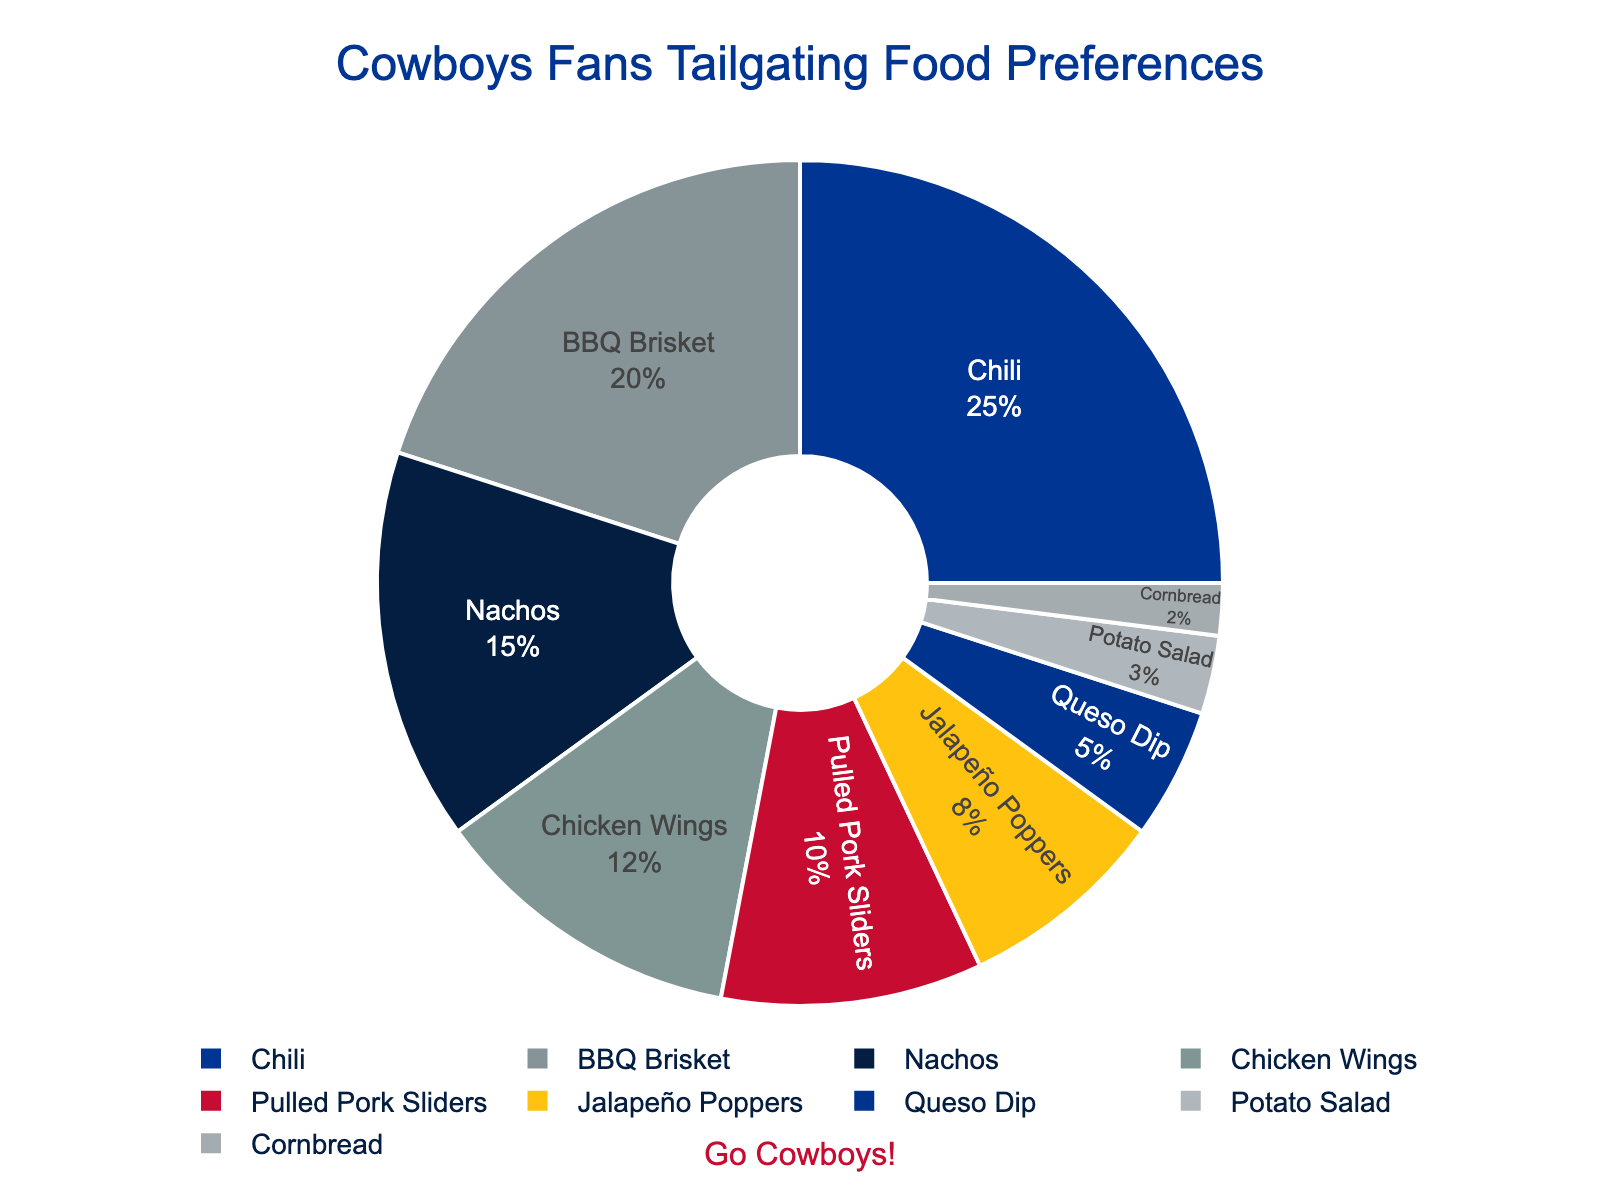What is the most preferred tailgating food item among Cowboys fans? The figure shows different food items with their percentages. The segment with the largest percentage is the most preferred.
Answer: Chili Which food item is less preferred: Chicken Wings or Pulled Pork Sliders? Locate both food items on the pie chart and compare their percentages. Chicken Wings have 12% and Pulled Pork Sliders have 10%.
Answer: Pulled Pork Sliders What’s the combined percentage of BBQ Brisket and Queso Dip? Identify the percentages for BBQ Brisket (20%) and Queso Dip (5%). Add them together: 20% + 5% = 25%.
Answer: 25% Among Jalapeño Poppers, Potato Salad, and Cornbread, which one has the second highest preference? Jalapeño Poppers have 8%, Potato Salad has 3%, and Cornbread has 2%. The second highest percentage among these is Potato Salad at 3%.
Answer: Potato Salad How much more popular is Nachos compared to Queso Dip? Nachos have a percentage of 15% while Queso Dip has 5%. Calculate the difference: 15% - 5% = 10%.
Answer: 10% Which food items have a combined percentage of 50%? Sum the percentages of food items one by one until reaching or exceeding 50%. Chili (25%) + BBQ Brisket (20%) + Nachos (15%) exceeds 50%.
Answer: Chili, BBQ Brisket, and Nachos What is the least preferred tailgating food item? Locate the smallest segment in the pie chart, which represents the least preferred food item. Cornbread is the smallest at 2%.
Answer: Cornbread Is the combined percentage of Chicken Wings and Pulled Pork Sliders greater than that of BBQ Brisket? Chicken Wings (12%) + Pulled Pork Sliders (10%) gives a combined percentage of 22%. Compare it with BBQ Brisket’s percentage (20%).
Answer: Yes Which two food items together make up the same percentage as Chili alone? Chili has 25%. Identify two items that sum up to 25%. BBQ Brisket (20%) + Queso Dip (5%) = 25%.
Answer: BBQ Brisket and Queso Dip What is the percentage difference between the most preferred and least preferred food item? The most preferred food item, Chili, has 25%, and the least preferred, Cornbread, has 2%. Calculate the difference: 25% - 2% = 23%.
Answer: 23% 